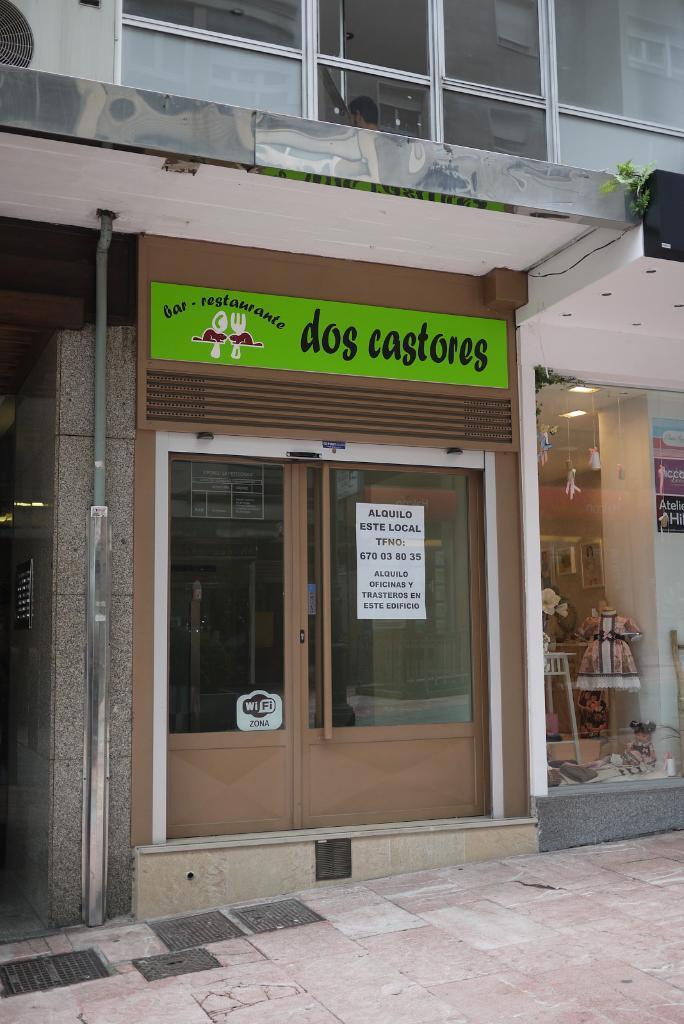Could you give a brief overview of what you see in this image? In this picture we can see the ground and in the background we can see a building and some objects. 